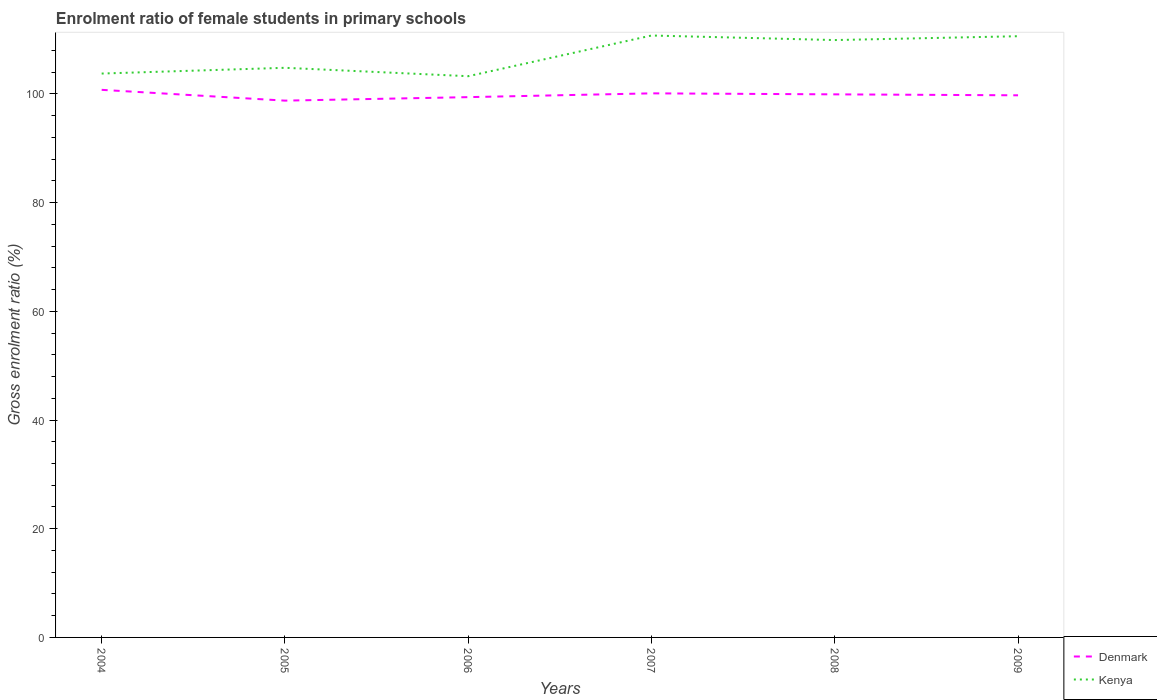How many different coloured lines are there?
Offer a very short reply. 2. Does the line corresponding to Denmark intersect with the line corresponding to Kenya?
Provide a succinct answer. No. Across all years, what is the maximum enrolment ratio of female students in primary schools in Kenya?
Provide a succinct answer. 103.25. What is the total enrolment ratio of female students in primary schools in Denmark in the graph?
Your response must be concise. 1.34. What is the difference between the highest and the second highest enrolment ratio of female students in primary schools in Kenya?
Keep it short and to the point. 7.49. Is the enrolment ratio of female students in primary schools in Denmark strictly greater than the enrolment ratio of female students in primary schools in Kenya over the years?
Give a very brief answer. Yes. How many years are there in the graph?
Give a very brief answer. 6. Does the graph contain grids?
Offer a terse response. No. How many legend labels are there?
Offer a very short reply. 2. What is the title of the graph?
Offer a very short reply. Enrolment ratio of female students in primary schools. Does "Bahamas" appear as one of the legend labels in the graph?
Provide a short and direct response. No. What is the label or title of the X-axis?
Your response must be concise. Years. What is the Gross enrolment ratio (%) of Denmark in 2004?
Your response must be concise. 100.74. What is the Gross enrolment ratio (%) of Kenya in 2004?
Make the answer very short. 103.74. What is the Gross enrolment ratio (%) of Denmark in 2005?
Your response must be concise. 98.76. What is the Gross enrolment ratio (%) in Kenya in 2005?
Your response must be concise. 104.8. What is the Gross enrolment ratio (%) of Denmark in 2006?
Your answer should be compact. 99.4. What is the Gross enrolment ratio (%) in Kenya in 2006?
Keep it short and to the point. 103.25. What is the Gross enrolment ratio (%) in Denmark in 2007?
Offer a very short reply. 100.1. What is the Gross enrolment ratio (%) in Kenya in 2007?
Provide a short and direct response. 110.74. What is the Gross enrolment ratio (%) in Denmark in 2008?
Provide a succinct answer. 99.91. What is the Gross enrolment ratio (%) in Kenya in 2008?
Your response must be concise. 109.9. What is the Gross enrolment ratio (%) in Denmark in 2009?
Provide a short and direct response. 99.74. What is the Gross enrolment ratio (%) of Kenya in 2009?
Provide a short and direct response. 110.61. Across all years, what is the maximum Gross enrolment ratio (%) in Denmark?
Ensure brevity in your answer.  100.74. Across all years, what is the maximum Gross enrolment ratio (%) of Kenya?
Provide a succinct answer. 110.74. Across all years, what is the minimum Gross enrolment ratio (%) in Denmark?
Provide a succinct answer. 98.76. Across all years, what is the minimum Gross enrolment ratio (%) of Kenya?
Ensure brevity in your answer.  103.25. What is the total Gross enrolment ratio (%) of Denmark in the graph?
Ensure brevity in your answer.  598.64. What is the total Gross enrolment ratio (%) of Kenya in the graph?
Ensure brevity in your answer.  643.03. What is the difference between the Gross enrolment ratio (%) of Denmark in 2004 and that in 2005?
Provide a succinct answer. 1.99. What is the difference between the Gross enrolment ratio (%) of Kenya in 2004 and that in 2005?
Provide a succinct answer. -1.06. What is the difference between the Gross enrolment ratio (%) of Denmark in 2004 and that in 2006?
Offer a terse response. 1.34. What is the difference between the Gross enrolment ratio (%) of Kenya in 2004 and that in 2006?
Offer a terse response. 0.49. What is the difference between the Gross enrolment ratio (%) in Denmark in 2004 and that in 2007?
Your response must be concise. 0.65. What is the difference between the Gross enrolment ratio (%) in Kenya in 2004 and that in 2007?
Provide a succinct answer. -7. What is the difference between the Gross enrolment ratio (%) of Denmark in 2004 and that in 2008?
Give a very brief answer. 0.83. What is the difference between the Gross enrolment ratio (%) in Kenya in 2004 and that in 2008?
Your answer should be very brief. -6.16. What is the difference between the Gross enrolment ratio (%) in Denmark in 2004 and that in 2009?
Your response must be concise. 1.01. What is the difference between the Gross enrolment ratio (%) in Kenya in 2004 and that in 2009?
Your answer should be compact. -6.87. What is the difference between the Gross enrolment ratio (%) of Denmark in 2005 and that in 2006?
Your response must be concise. -0.64. What is the difference between the Gross enrolment ratio (%) in Kenya in 2005 and that in 2006?
Keep it short and to the point. 1.55. What is the difference between the Gross enrolment ratio (%) in Denmark in 2005 and that in 2007?
Give a very brief answer. -1.34. What is the difference between the Gross enrolment ratio (%) of Kenya in 2005 and that in 2007?
Offer a very short reply. -5.94. What is the difference between the Gross enrolment ratio (%) of Denmark in 2005 and that in 2008?
Your answer should be very brief. -1.16. What is the difference between the Gross enrolment ratio (%) of Kenya in 2005 and that in 2008?
Provide a succinct answer. -5.1. What is the difference between the Gross enrolment ratio (%) of Denmark in 2005 and that in 2009?
Your response must be concise. -0.98. What is the difference between the Gross enrolment ratio (%) of Kenya in 2005 and that in 2009?
Offer a very short reply. -5.81. What is the difference between the Gross enrolment ratio (%) in Denmark in 2006 and that in 2007?
Your response must be concise. -0.7. What is the difference between the Gross enrolment ratio (%) in Kenya in 2006 and that in 2007?
Provide a succinct answer. -7.49. What is the difference between the Gross enrolment ratio (%) of Denmark in 2006 and that in 2008?
Your response must be concise. -0.51. What is the difference between the Gross enrolment ratio (%) of Kenya in 2006 and that in 2008?
Your answer should be compact. -6.65. What is the difference between the Gross enrolment ratio (%) of Denmark in 2006 and that in 2009?
Offer a very short reply. -0.34. What is the difference between the Gross enrolment ratio (%) of Kenya in 2006 and that in 2009?
Make the answer very short. -7.36. What is the difference between the Gross enrolment ratio (%) in Denmark in 2007 and that in 2008?
Ensure brevity in your answer.  0.18. What is the difference between the Gross enrolment ratio (%) of Kenya in 2007 and that in 2008?
Offer a terse response. 0.84. What is the difference between the Gross enrolment ratio (%) of Denmark in 2007 and that in 2009?
Provide a short and direct response. 0.36. What is the difference between the Gross enrolment ratio (%) of Kenya in 2007 and that in 2009?
Your answer should be very brief. 0.13. What is the difference between the Gross enrolment ratio (%) in Denmark in 2008 and that in 2009?
Your answer should be very brief. 0.18. What is the difference between the Gross enrolment ratio (%) of Kenya in 2008 and that in 2009?
Ensure brevity in your answer.  -0.71. What is the difference between the Gross enrolment ratio (%) in Denmark in 2004 and the Gross enrolment ratio (%) in Kenya in 2005?
Your answer should be compact. -4.06. What is the difference between the Gross enrolment ratio (%) of Denmark in 2004 and the Gross enrolment ratio (%) of Kenya in 2006?
Your response must be concise. -2.51. What is the difference between the Gross enrolment ratio (%) of Denmark in 2004 and the Gross enrolment ratio (%) of Kenya in 2007?
Keep it short and to the point. -10. What is the difference between the Gross enrolment ratio (%) in Denmark in 2004 and the Gross enrolment ratio (%) in Kenya in 2008?
Keep it short and to the point. -9.16. What is the difference between the Gross enrolment ratio (%) of Denmark in 2004 and the Gross enrolment ratio (%) of Kenya in 2009?
Your answer should be very brief. -9.87. What is the difference between the Gross enrolment ratio (%) in Denmark in 2005 and the Gross enrolment ratio (%) in Kenya in 2006?
Keep it short and to the point. -4.49. What is the difference between the Gross enrolment ratio (%) of Denmark in 2005 and the Gross enrolment ratio (%) of Kenya in 2007?
Offer a terse response. -11.98. What is the difference between the Gross enrolment ratio (%) of Denmark in 2005 and the Gross enrolment ratio (%) of Kenya in 2008?
Your response must be concise. -11.14. What is the difference between the Gross enrolment ratio (%) of Denmark in 2005 and the Gross enrolment ratio (%) of Kenya in 2009?
Make the answer very short. -11.85. What is the difference between the Gross enrolment ratio (%) in Denmark in 2006 and the Gross enrolment ratio (%) in Kenya in 2007?
Provide a short and direct response. -11.34. What is the difference between the Gross enrolment ratio (%) in Denmark in 2006 and the Gross enrolment ratio (%) in Kenya in 2008?
Make the answer very short. -10.5. What is the difference between the Gross enrolment ratio (%) in Denmark in 2006 and the Gross enrolment ratio (%) in Kenya in 2009?
Give a very brief answer. -11.21. What is the difference between the Gross enrolment ratio (%) of Denmark in 2007 and the Gross enrolment ratio (%) of Kenya in 2008?
Keep it short and to the point. -9.8. What is the difference between the Gross enrolment ratio (%) in Denmark in 2007 and the Gross enrolment ratio (%) in Kenya in 2009?
Provide a short and direct response. -10.51. What is the difference between the Gross enrolment ratio (%) of Denmark in 2008 and the Gross enrolment ratio (%) of Kenya in 2009?
Keep it short and to the point. -10.7. What is the average Gross enrolment ratio (%) of Denmark per year?
Offer a very short reply. 99.77. What is the average Gross enrolment ratio (%) in Kenya per year?
Offer a very short reply. 107.17. In the year 2004, what is the difference between the Gross enrolment ratio (%) of Denmark and Gross enrolment ratio (%) of Kenya?
Your answer should be compact. -3. In the year 2005, what is the difference between the Gross enrolment ratio (%) of Denmark and Gross enrolment ratio (%) of Kenya?
Provide a short and direct response. -6.04. In the year 2006, what is the difference between the Gross enrolment ratio (%) in Denmark and Gross enrolment ratio (%) in Kenya?
Offer a very short reply. -3.85. In the year 2007, what is the difference between the Gross enrolment ratio (%) of Denmark and Gross enrolment ratio (%) of Kenya?
Your answer should be compact. -10.64. In the year 2008, what is the difference between the Gross enrolment ratio (%) in Denmark and Gross enrolment ratio (%) in Kenya?
Provide a succinct answer. -9.99. In the year 2009, what is the difference between the Gross enrolment ratio (%) in Denmark and Gross enrolment ratio (%) in Kenya?
Your answer should be very brief. -10.87. What is the ratio of the Gross enrolment ratio (%) of Denmark in 2004 to that in 2005?
Offer a very short reply. 1.02. What is the ratio of the Gross enrolment ratio (%) of Kenya in 2004 to that in 2005?
Keep it short and to the point. 0.99. What is the ratio of the Gross enrolment ratio (%) of Denmark in 2004 to that in 2006?
Keep it short and to the point. 1.01. What is the ratio of the Gross enrolment ratio (%) in Kenya in 2004 to that in 2007?
Your answer should be very brief. 0.94. What is the ratio of the Gross enrolment ratio (%) of Denmark in 2004 to that in 2008?
Make the answer very short. 1.01. What is the ratio of the Gross enrolment ratio (%) of Kenya in 2004 to that in 2008?
Your answer should be very brief. 0.94. What is the ratio of the Gross enrolment ratio (%) in Kenya in 2004 to that in 2009?
Provide a short and direct response. 0.94. What is the ratio of the Gross enrolment ratio (%) in Denmark in 2005 to that in 2006?
Offer a very short reply. 0.99. What is the ratio of the Gross enrolment ratio (%) in Kenya in 2005 to that in 2006?
Offer a very short reply. 1.01. What is the ratio of the Gross enrolment ratio (%) of Denmark in 2005 to that in 2007?
Keep it short and to the point. 0.99. What is the ratio of the Gross enrolment ratio (%) in Kenya in 2005 to that in 2007?
Your answer should be compact. 0.95. What is the ratio of the Gross enrolment ratio (%) in Denmark in 2005 to that in 2008?
Offer a very short reply. 0.99. What is the ratio of the Gross enrolment ratio (%) in Kenya in 2005 to that in 2008?
Offer a terse response. 0.95. What is the ratio of the Gross enrolment ratio (%) in Denmark in 2005 to that in 2009?
Your response must be concise. 0.99. What is the ratio of the Gross enrolment ratio (%) in Kenya in 2005 to that in 2009?
Your answer should be very brief. 0.95. What is the ratio of the Gross enrolment ratio (%) of Denmark in 2006 to that in 2007?
Give a very brief answer. 0.99. What is the ratio of the Gross enrolment ratio (%) of Kenya in 2006 to that in 2007?
Keep it short and to the point. 0.93. What is the ratio of the Gross enrolment ratio (%) in Denmark in 2006 to that in 2008?
Keep it short and to the point. 0.99. What is the ratio of the Gross enrolment ratio (%) of Kenya in 2006 to that in 2008?
Provide a succinct answer. 0.94. What is the ratio of the Gross enrolment ratio (%) in Denmark in 2006 to that in 2009?
Your response must be concise. 1. What is the ratio of the Gross enrolment ratio (%) in Kenya in 2006 to that in 2009?
Make the answer very short. 0.93. What is the ratio of the Gross enrolment ratio (%) of Kenya in 2007 to that in 2008?
Make the answer very short. 1.01. What is the ratio of the Gross enrolment ratio (%) in Denmark in 2008 to that in 2009?
Offer a terse response. 1. What is the difference between the highest and the second highest Gross enrolment ratio (%) of Denmark?
Make the answer very short. 0.65. What is the difference between the highest and the second highest Gross enrolment ratio (%) of Kenya?
Keep it short and to the point. 0.13. What is the difference between the highest and the lowest Gross enrolment ratio (%) in Denmark?
Ensure brevity in your answer.  1.99. What is the difference between the highest and the lowest Gross enrolment ratio (%) of Kenya?
Provide a short and direct response. 7.49. 